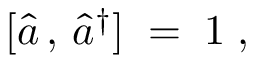<formula> <loc_0><loc_0><loc_500><loc_500>[ { \hat { a } } \, , \, { \hat { a } } ^ { \dagger } ] \, = \, 1 \, ,</formula> 